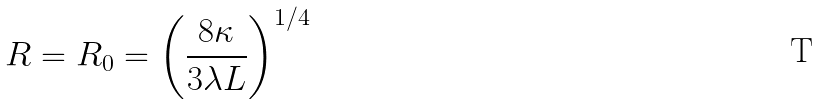Convert formula to latex. <formula><loc_0><loc_0><loc_500><loc_500>R = R _ { 0 } = \left ( \frac { 8 \kappa } { 3 \lambda L } \right ) ^ { 1 / 4 }</formula> 